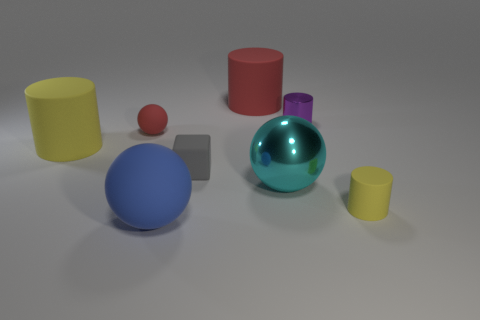How could we categorize the objects in terms of geometry? The objects in the image can be categorized by their geometric shapes. We see a variety of fundamental geometries: the gray object is a cube, representing a hexahedron with equal sides and right angles. The large blue and the small red objects are both cylinders, characterized by their circular bases and parallel sides. The large greenish-blue object is a sphere, notable for its round, perfectly symmetrical shape. Likewise, the small purple object appears to be a truncated cone, or a conical shape with the top cut off parallel to the base. Lastly, we have two objects that resemble round cylinders or tubes with different heights, colored in large yellow and small purple. 